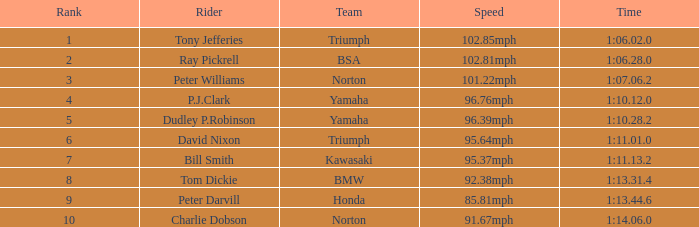At 9 1:10.12.0. 